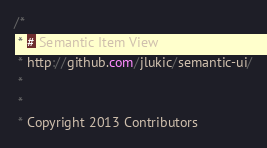Convert code to text. <code><loc_0><loc_0><loc_500><loc_500><_CSS_>/*
 * # Semantic Item View
 * http://github.com/jlukic/semantic-ui/
 *
 *
 * Copyright 2013 Contributors</code> 